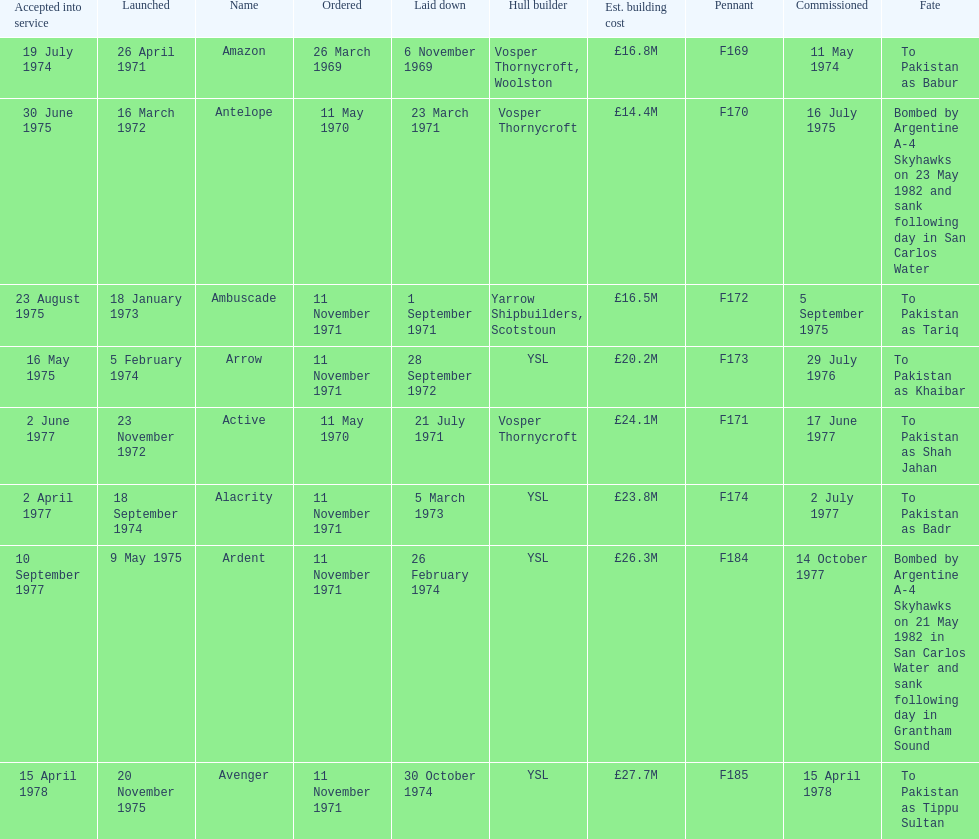How many ships were built after ardent? 1. 